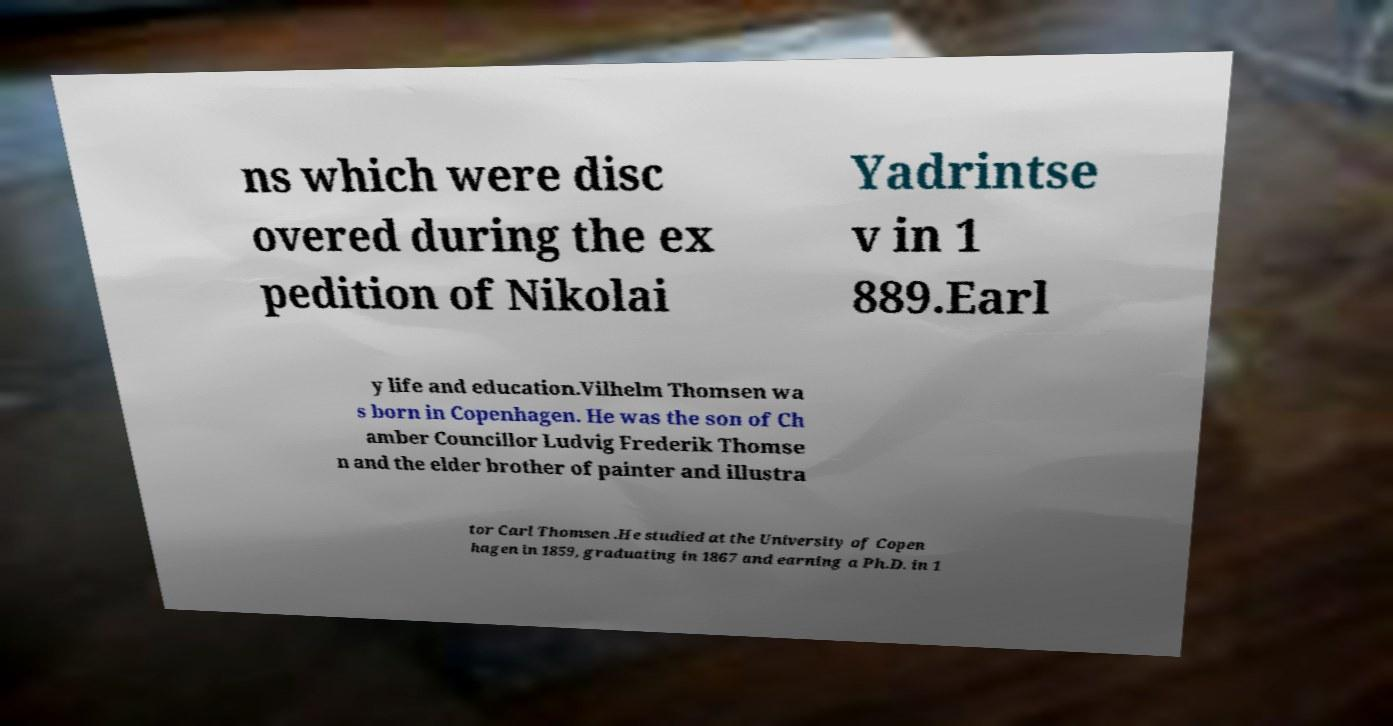Could you assist in decoding the text presented in this image and type it out clearly? ns which were disc overed during the ex pedition of Nikolai Yadrintse v in 1 889.Earl y life and education.Vilhelm Thomsen wa s born in Copenhagen. He was the son of Ch amber Councillor Ludvig Frederik Thomse n and the elder brother of painter and illustra tor Carl Thomsen .He studied at the University of Copen hagen in 1859, graduating in 1867 and earning a Ph.D. in 1 